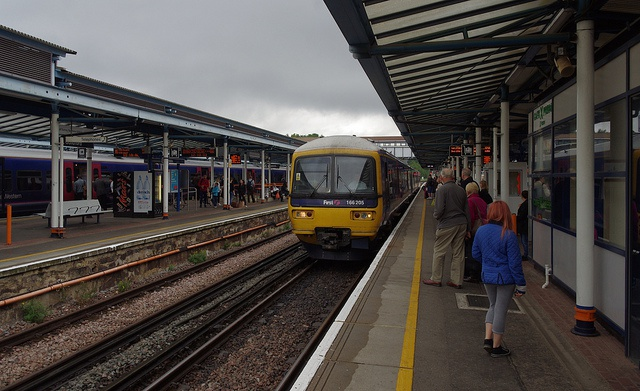Describe the objects in this image and their specific colors. I can see train in darkgray, black, gray, and olive tones, people in darkgray, navy, black, maroon, and gray tones, people in darkgray, black, and gray tones, train in darkgray, black, gray, and navy tones, and people in darkgray, black, gray, and maroon tones in this image. 